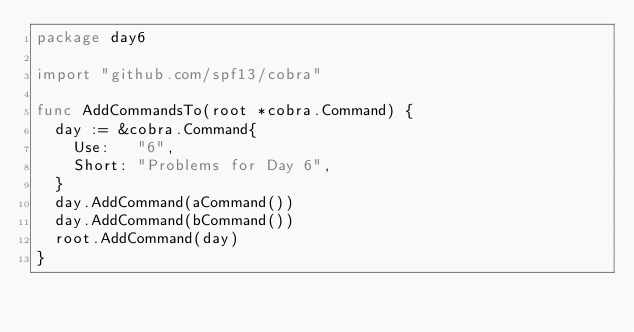<code> <loc_0><loc_0><loc_500><loc_500><_Go_>package day6

import "github.com/spf13/cobra"

func AddCommandsTo(root *cobra.Command) {
	day := &cobra.Command{
		Use:   "6",
		Short: "Problems for Day 6",
	}
	day.AddCommand(aCommand())
	day.AddCommand(bCommand())
	root.AddCommand(day)
}
</code> 